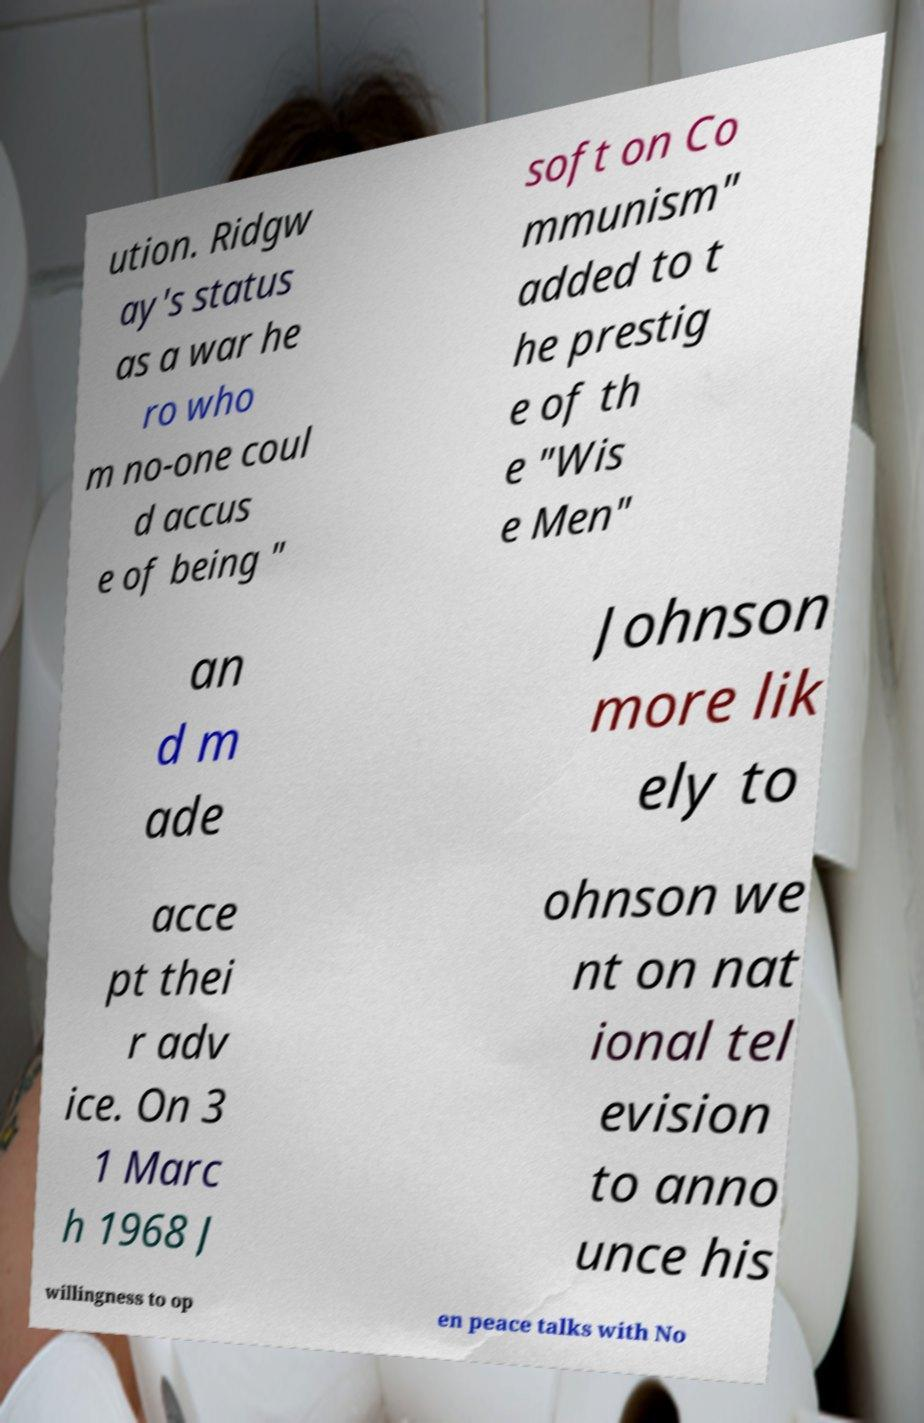Could you assist in decoding the text presented in this image and type it out clearly? ution. Ridgw ay's status as a war he ro who m no-one coul d accus e of being " soft on Co mmunism" added to t he prestig e of th e "Wis e Men" an d m ade Johnson more lik ely to acce pt thei r adv ice. On 3 1 Marc h 1968 J ohnson we nt on nat ional tel evision to anno unce his willingness to op en peace talks with No 